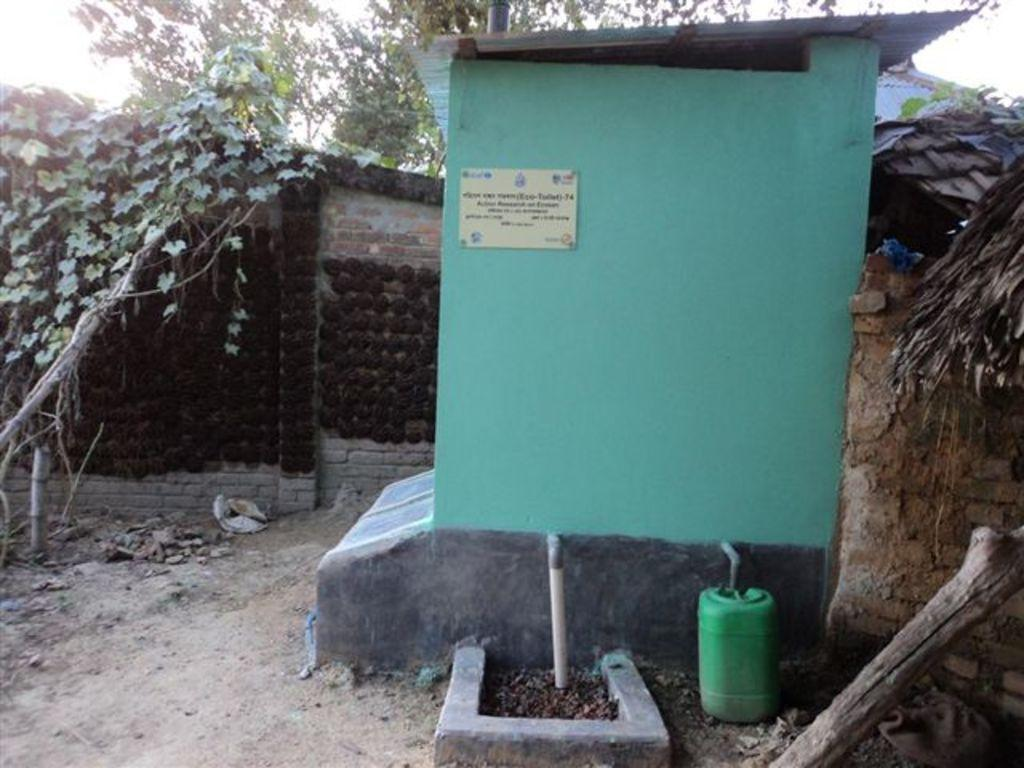What color is the house in the image? The house in the image is green in color. What else in the image shares the same color as the house? There is a green can in the image. Can you describe any objects related to plumbing in the image? Yes, there are two pipes in the image. What can be seen in the background of the image? There are trees, walls, and the sky visible in the background of the image. What type of spoon is hanging from the tree in the image? There is no spoon present in the image, let alone one hanging from a tree. 